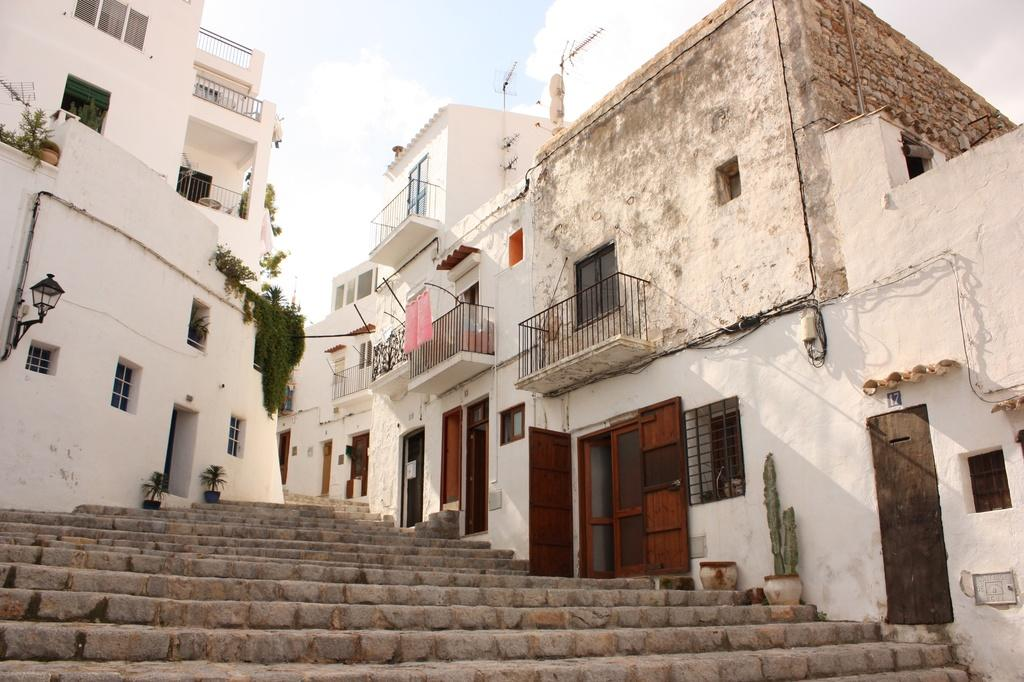What type of structures can be seen in the image? There are buildings in the image. What type of vegetation is present in the image? There are plants and flower pots in the image. What architectural features can be seen in the image? There are stairs, windows, doors, and iron grilles in the image. Can you describe the lighting in the image? There is light visible in the image. What can be seen in the background of the image? The sky is visible in the background of the image. What type of distribution system is visible in the image? There is no distribution system present in the image. What type of beam can be seen supporting the buildings in the image? There is no beam visible in the image; the buildings' support structures are not mentioned in the provided facts. 